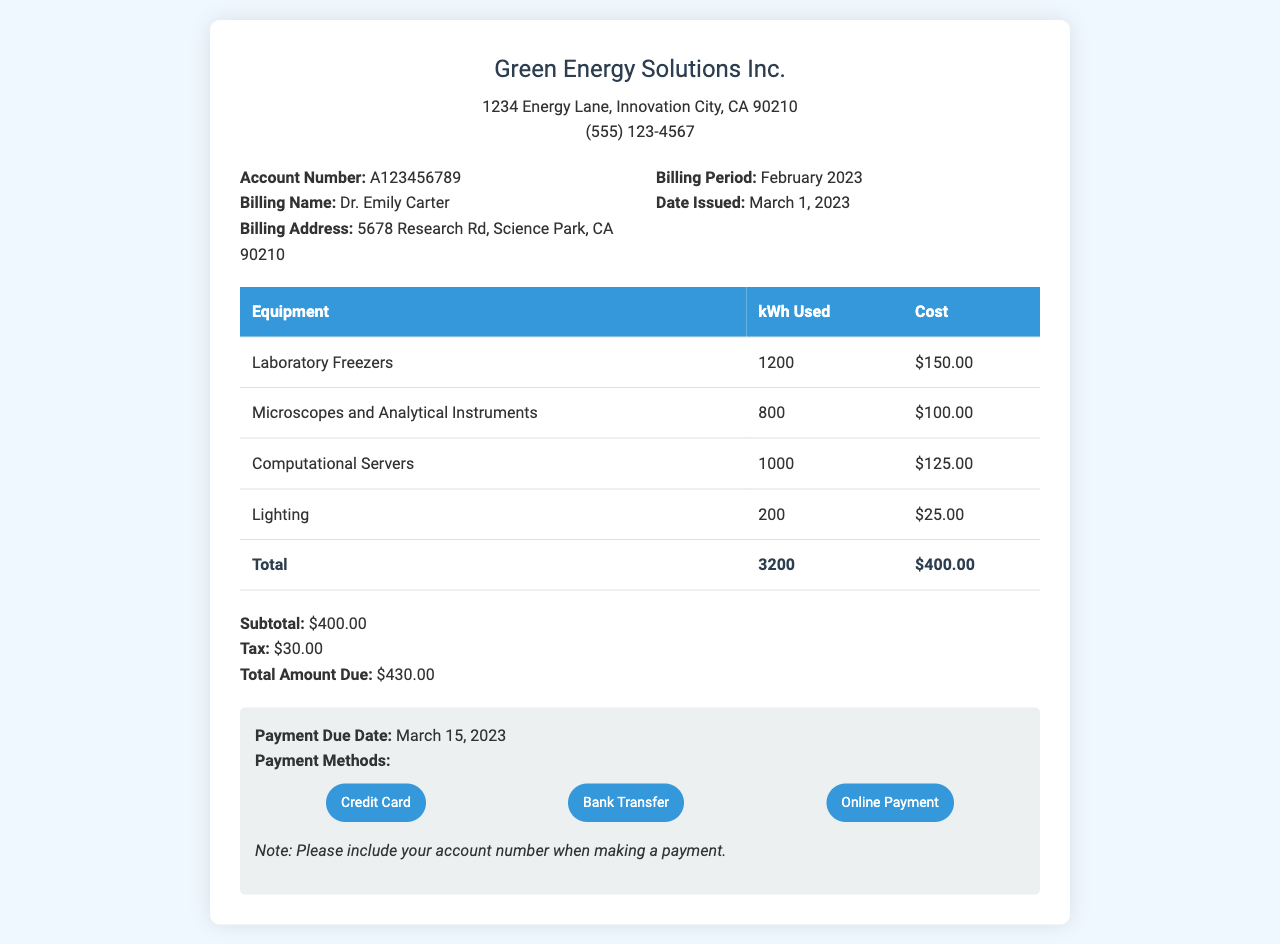What is the billing period? The billing period is clearly stated in the document as February 2023.
Answer: February 2023 What is the total amount due? The total amount due is calculated as the subtotal plus tax in the document, which is $400.00 + $30.00.
Answer: $430.00 Who is the billing name? The billing name is mentioned in the document as Dr. Emily Carter.
Answer: Dr. Emily Carter How much did the laboratory freezers cost? The cost for the laboratory freezers is provided in the breakdown, which is $150.00.
Answer: $150.00 What is the kWh used by computational servers? The document lists the energy usage for computational servers, which is 1000 kWh.
Answer: 1000 kWh What is the subtotal before tax? The subtotal is specifically shown in the document as $400.00 before tax is added.
Answer: $400.00 When is the payment due date? The payment due date is outlined in the document as March 15, 2023.
Answer: March 15, 2023 How much tax is applied to the bill? The document specifies the tax amount applied, which is $30.00.
Answer: $30.00 What address is listed for the billing? The billing address is found in the document as 5678 Research Rd, Science Park, CA 90210.
Answer: 5678 Research Rd, Science Park, CA 90210 